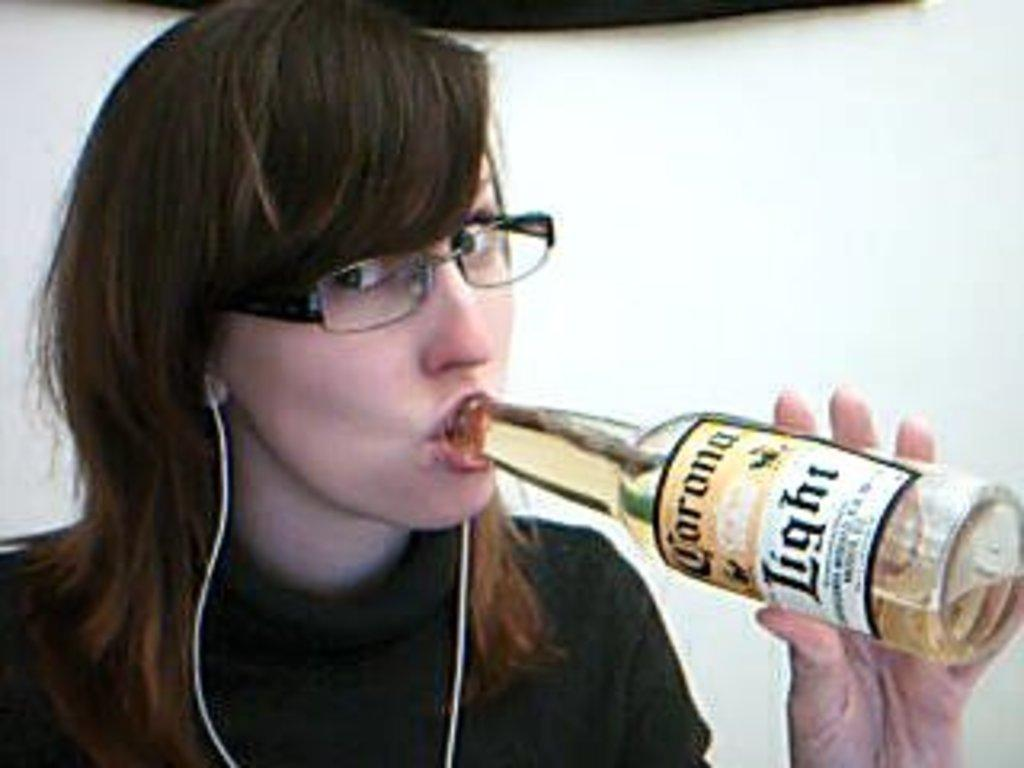Who is the main subject in the image? There is a girl in the image. What is the girl holding in the image? The girl is holding a bottle. What is the girl doing with the bottle? The girl is drinking from the bottle. Can you describe the bottle in the image? There is a label on the bottle. What type of dog is playing with the parcel in the image? There is no dog or parcel present in the image. 